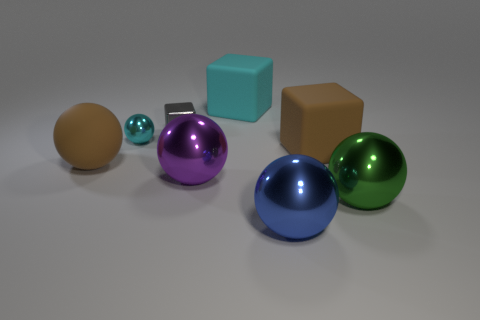Is the number of cyan rubber things that are right of the tiny gray shiny cube greater than the number of big cyan rubber objects on the right side of the blue metal thing?
Offer a terse response. Yes. What is the size of the cube that is the same color as the large matte ball?
Give a very brief answer. Large. There is a blue thing; is it the same size as the cyan metal sphere that is in front of the tiny gray cube?
Offer a terse response. No. What number of spheres are either red objects or large things?
Keep it short and to the point. 4. The cyan ball that is made of the same material as the big green sphere is what size?
Make the answer very short. Small. There is a purple ball that is on the right side of the big brown matte ball; is it the same size as the brown matte thing to the left of the large blue ball?
Ensure brevity in your answer.  Yes. What number of objects are large green shiny things or big cyan objects?
Your response must be concise. 2. The gray metal object is what shape?
Your answer should be compact. Cube. The other rubber thing that is the same shape as the green thing is what size?
Keep it short and to the point. Large. Is there anything else that is made of the same material as the gray object?
Your response must be concise. Yes. 